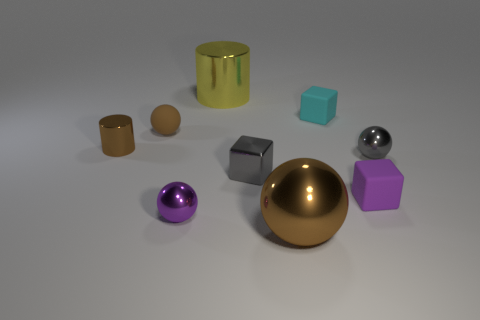Subtract all brown spheres. How many were subtracted if there are1brown spheres left? 1 Subtract all tiny purple cubes. How many cubes are left? 2 Subtract all purple cylinders. How many brown balls are left? 2 Subtract all purple balls. How many balls are left? 3 Subtract 1 cubes. How many cubes are left? 2 Subtract all cubes. How many objects are left? 6 Subtract all yellow balls. Subtract all green blocks. How many balls are left? 4 Add 2 cyan blocks. How many cyan blocks exist? 3 Subtract 0 green spheres. How many objects are left? 9 Subtract all gray metal blocks. Subtract all small shiny cylinders. How many objects are left? 7 